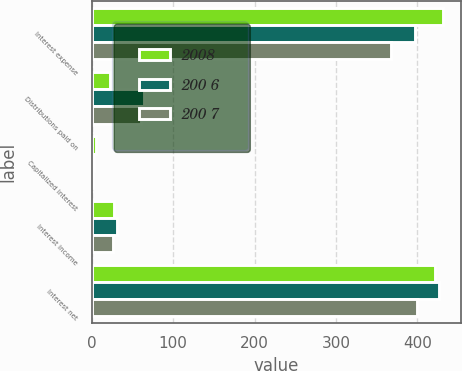<chart> <loc_0><loc_0><loc_500><loc_500><stacked_bar_chart><ecel><fcel>Interest expense<fcel>Distributions paid on<fcel>Capitalized interest<fcel>Interest income<fcel>Interest net<nl><fcel>2008<fcel>432<fcel>22<fcel>5<fcel>27.3<fcel>421.7<nl><fcel>200 6<fcel>396.6<fcel>63.8<fcel>2.5<fcel>31.4<fcel>426.5<nl><fcel>200 7<fcel>367<fcel>60.5<fcel>1.1<fcel>26.8<fcel>399.6<nl></chart> 